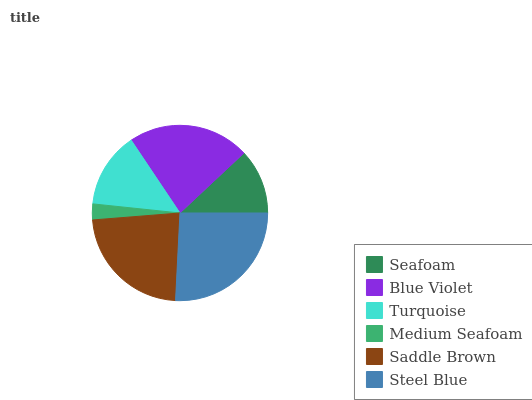Is Medium Seafoam the minimum?
Answer yes or no. Yes. Is Steel Blue the maximum?
Answer yes or no. Yes. Is Blue Violet the minimum?
Answer yes or no. No. Is Blue Violet the maximum?
Answer yes or no. No. Is Blue Violet greater than Seafoam?
Answer yes or no. Yes. Is Seafoam less than Blue Violet?
Answer yes or no. Yes. Is Seafoam greater than Blue Violet?
Answer yes or no. No. Is Blue Violet less than Seafoam?
Answer yes or no. No. Is Blue Violet the high median?
Answer yes or no. Yes. Is Turquoise the low median?
Answer yes or no. Yes. Is Saddle Brown the high median?
Answer yes or no. No. Is Saddle Brown the low median?
Answer yes or no. No. 